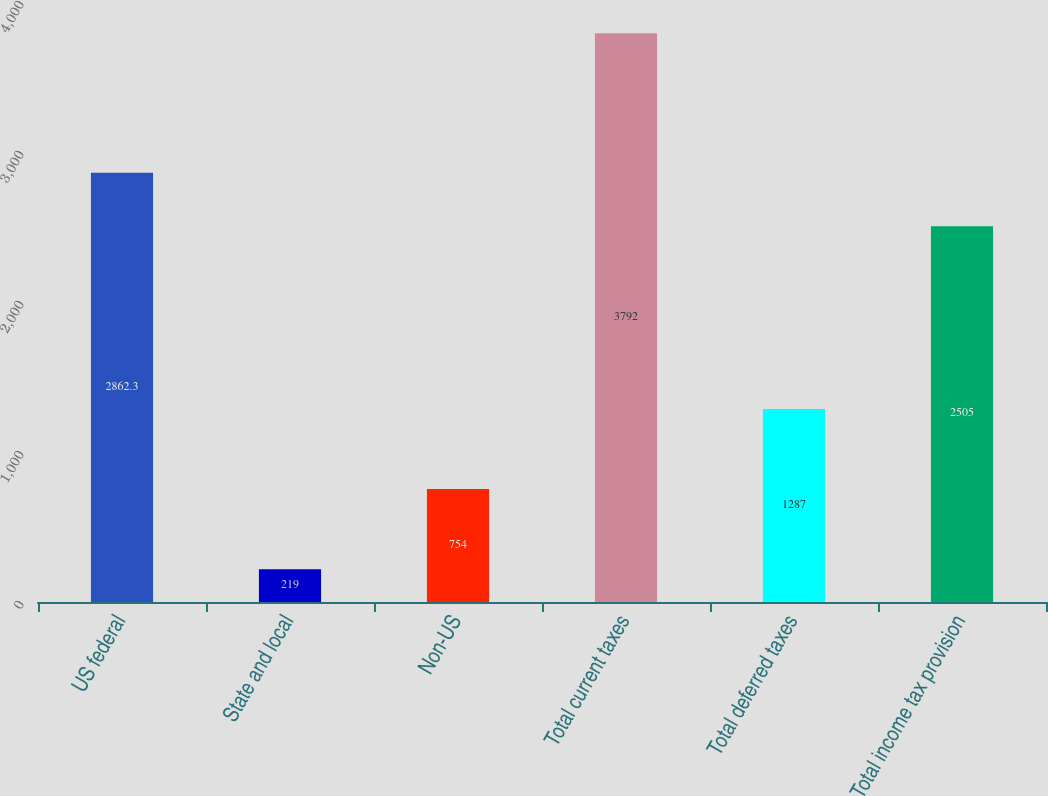Convert chart. <chart><loc_0><loc_0><loc_500><loc_500><bar_chart><fcel>US federal<fcel>State and local<fcel>Non-US<fcel>Total current taxes<fcel>Total deferred taxes<fcel>Total income tax provision<nl><fcel>2862.3<fcel>219<fcel>754<fcel>3792<fcel>1287<fcel>2505<nl></chart> 